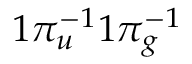Convert formula to latex. <formula><loc_0><loc_0><loc_500><loc_500>1 \pi _ { u } ^ { - 1 } 1 \pi _ { g } ^ { - 1 }</formula> 